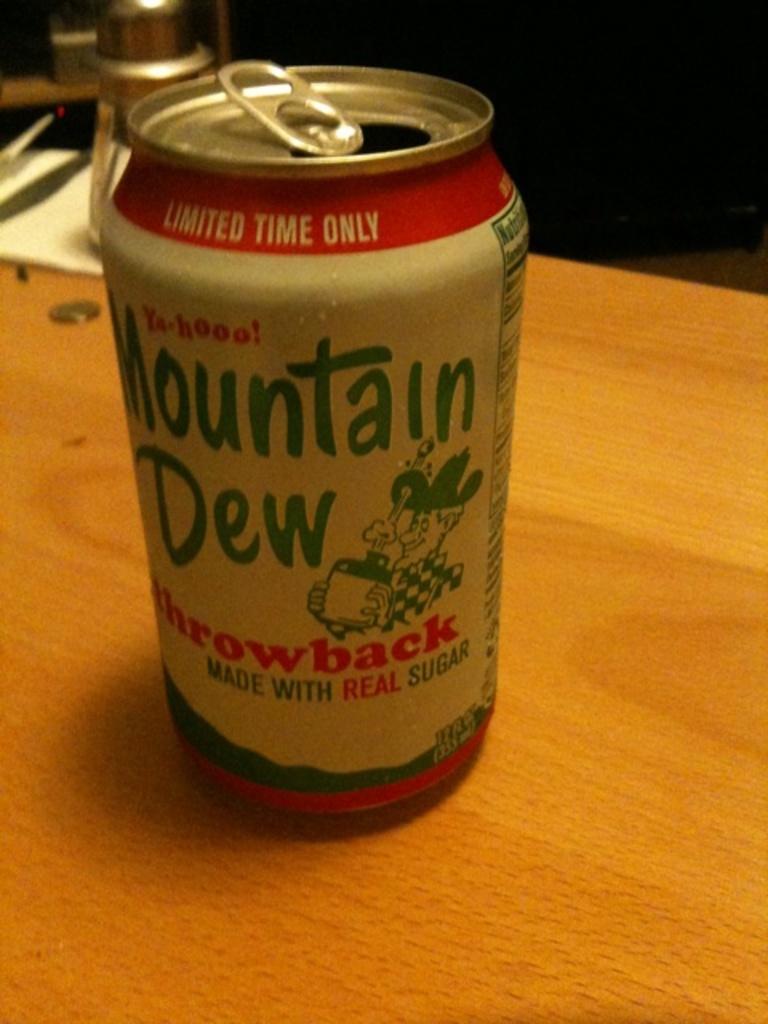How long is this soda pop available for?
Provide a succinct answer. Limited time. What brand of soda is this?
Give a very brief answer. Mountain dew. 